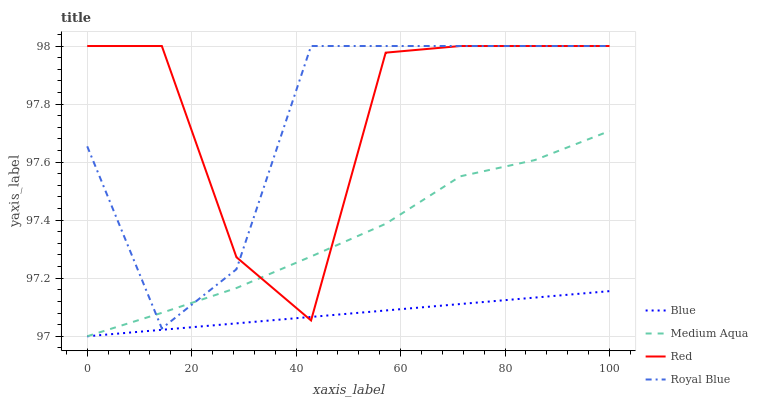Does Blue have the minimum area under the curve?
Answer yes or no. Yes. Does Royal Blue have the minimum area under the curve?
Answer yes or no. No. Does Royal Blue have the maximum area under the curve?
Answer yes or no. No. Is Red the roughest?
Answer yes or no. Yes. Is Royal Blue the smoothest?
Answer yes or no. No. Is Royal Blue the roughest?
Answer yes or no. No. Does Royal Blue have the lowest value?
Answer yes or no. No. Does Medium Aqua have the highest value?
Answer yes or no. No. Is Blue less than Royal Blue?
Answer yes or no. Yes. Is Royal Blue greater than Blue?
Answer yes or no. Yes. Does Blue intersect Royal Blue?
Answer yes or no. No. 